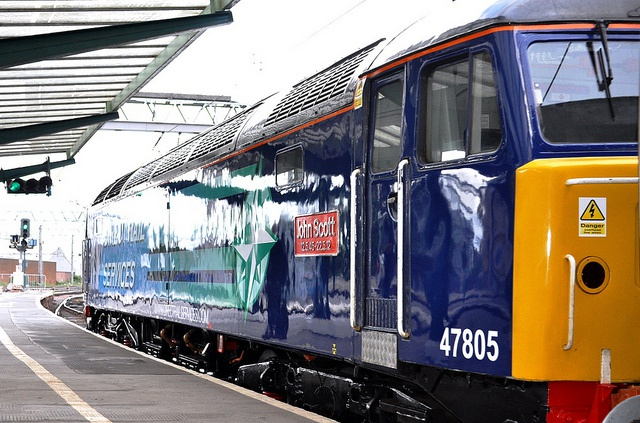Describe the objects in this image and their specific colors. I can see train in gray, black, navy, and white tones, traffic light in gray, black, teal, and green tones, and traffic light in gray and black tones in this image. 